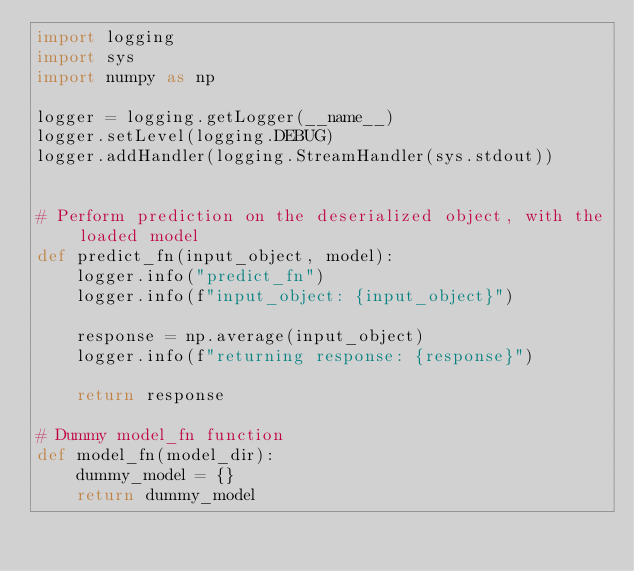<code> <loc_0><loc_0><loc_500><loc_500><_Python_>import logging
import sys
import numpy as np

logger = logging.getLogger(__name__)
logger.setLevel(logging.DEBUG)
logger.addHandler(logging.StreamHandler(sys.stdout))


# Perform prediction on the deserialized object, with the loaded model
def predict_fn(input_object, model):
    logger.info("predict_fn")
    logger.info(f"input_object: {input_object}")

    response = np.average(input_object)
    logger.info(f"returning response: {response}")

    return response

# Dummy model_fn function
def model_fn(model_dir):
    dummy_model = {}
    return dummy_model</code> 